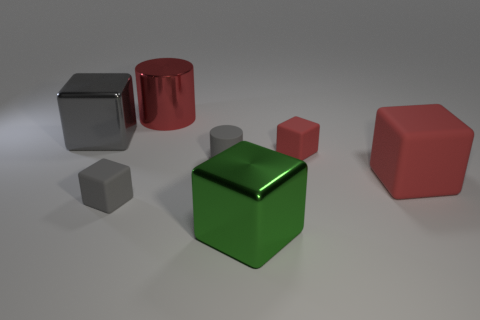What number of cubes are either small objects or green objects?
Keep it short and to the point. 3. What size is the metal cube that is behind the small gray matte object that is behind the tiny gray object on the left side of the rubber cylinder?
Provide a succinct answer. Large. There is a green metallic thing that is the same size as the metal cylinder; what is its shape?
Provide a succinct answer. Cube. The tiny red object is what shape?
Your answer should be very brief. Cube. Are the big block to the left of the green metallic thing and the large green block made of the same material?
Your response must be concise. Yes. There is a gray cube that is in front of the large metallic block behind the large green object; what is its size?
Offer a very short reply. Small. There is a big metal object that is both to the left of the green object and on the right side of the big gray thing; what color is it?
Your response must be concise. Red. There is a red object that is the same size as the gray matte cylinder; what is it made of?
Your answer should be very brief. Rubber. How many other things are there of the same material as the large red cylinder?
Your answer should be compact. 2. There is a small object behind the small gray rubber cylinder; is its color the same as the cylinder to the left of the gray rubber cylinder?
Make the answer very short. Yes. 